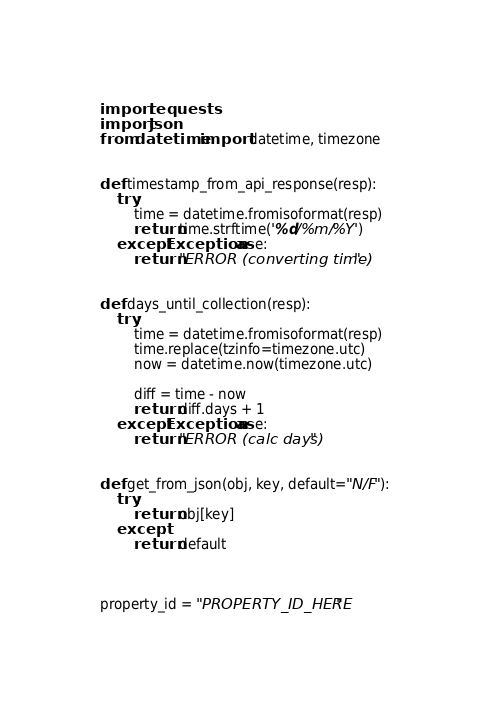<code> <loc_0><loc_0><loc_500><loc_500><_Python_>import requests
import json
from datetime import datetime, timezone


def timestamp_from_api_response(resp):
    try:
        time = datetime.fromisoformat(resp)
        return time.strftime('%d/%m/%Y')
    except Exception as e:
        return "ERROR (converting time)"


def days_until_collection(resp):
    try:
        time = datetime.fromisoformat(resp)
        time.replace(tzinfo=timezone.utc)
        now = datetime.now(timezone.utc)

        diff = time - now
        return diff.days + 1
    except Exception as e:
        return "ERROR (calc days)"


def get_from_json(obj, key, default="N/F"):
    try:
        return obj[key]
    except:
        return default



property_id = "PROPERTY_ID_HERE"</code> 